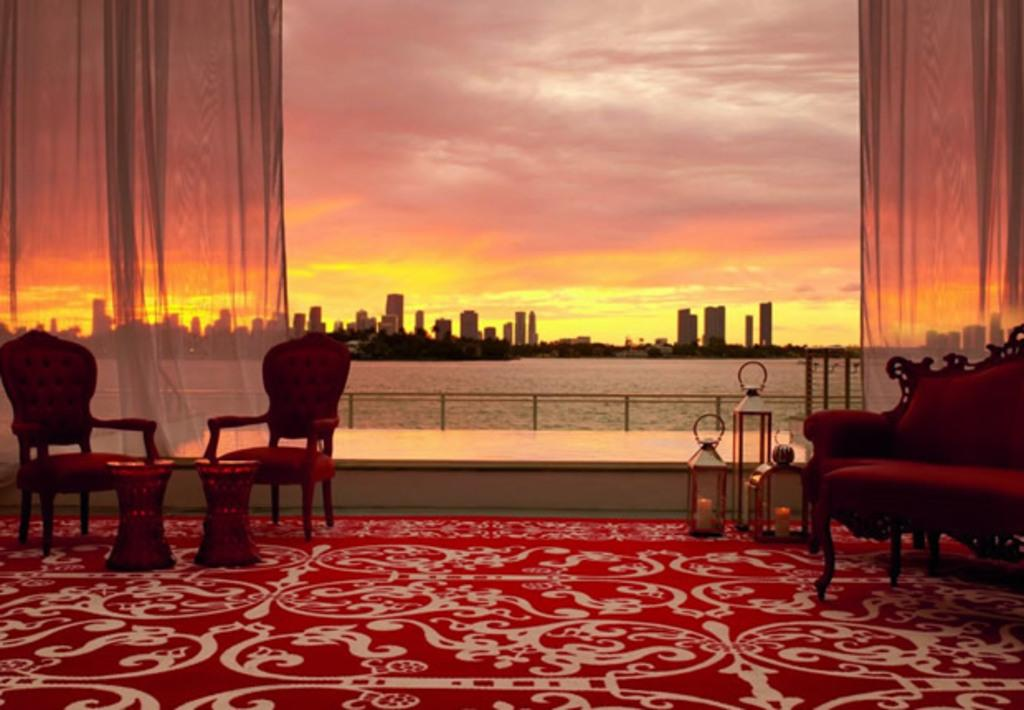Where was the image taken? The image was taken in a room. What furniture is present in the room? There are chairs, a table, and a sofa in the room. What can be seen in the background of the room? The background of the room includes water, a building, and the sky. What type of brass instrument is being played by the manager in the image? There is no manager or brass instrument present in the image. Can you see any jellyfish in the water visible in the background of the room? There are no jellyfish visible in the water in the background of the room. 